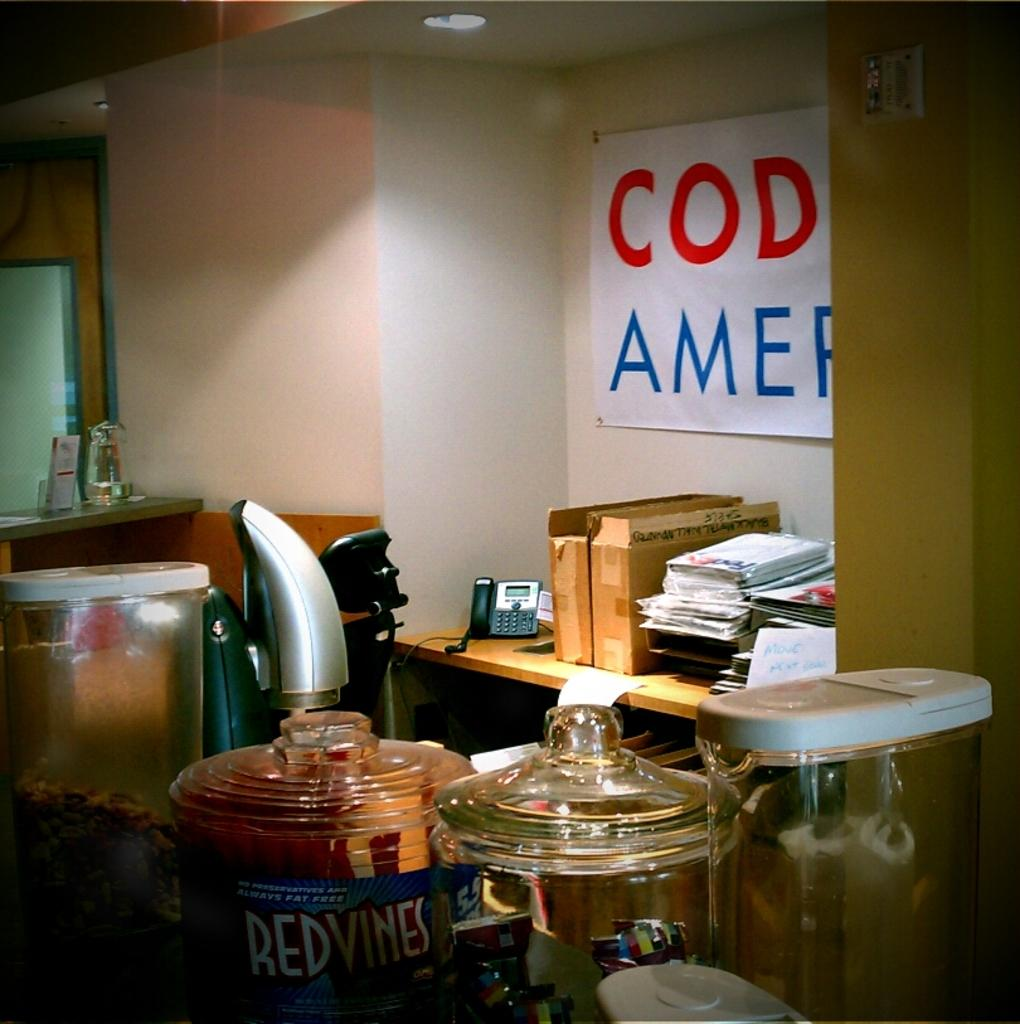Provide a one-sentence caption for the provided image. A office with a banner maybe saying something about America. 